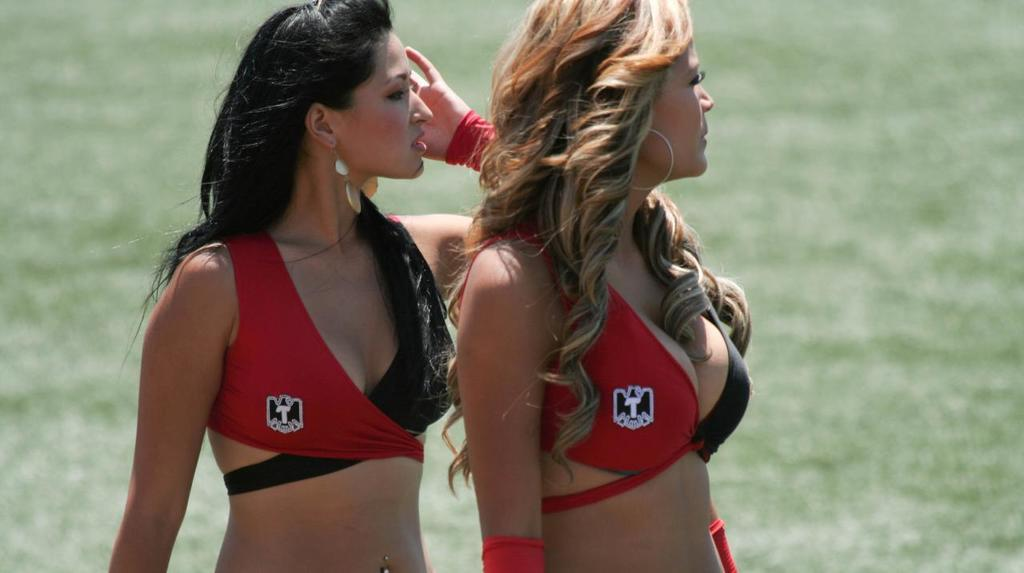<image>
Render a clear and concise summary of the photo. Two women wearing identical tops that have an emblem with a T in the middle. 